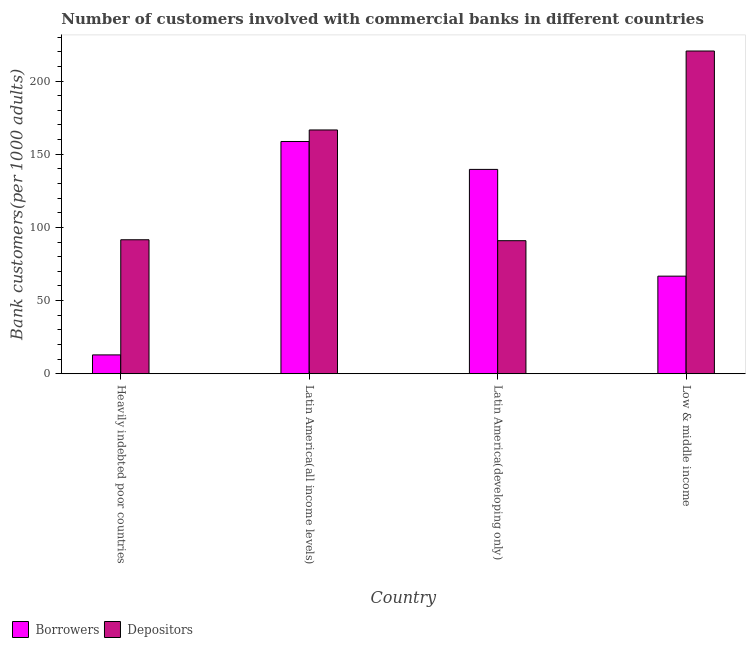How many groups of bars are there?
Give a very brief answer. 4. Are the number of bars on each tick of the X-axis equal?
Your response must be concise. Yes. How many bars are there on the 1st tick from the left?
Offer a very short reply. 2. What is the label of the 1st group of bars from the left?
Your response must be concise. Heavily indebted poor countries. What is the number of borrowers in Low & middle income?
Offer a terse response. 66.68. Across all countries, what is the maximum number of depositors?
Your answer should be compact. 220.51. Across all countries, what is the minimum number of borrowers?
Your response must be concise. 12.87. In which country was the number of depositors maximum?
Your answer should be very brief. Low & middle income. In which country was the number of depositors minimum?
Your response must be concise. Latin America(developing only). What is the total number of borrowers in the graph?
Offer a very short reply. 377.86. What is the difference between the number of borrowers in Heavily indebted poor countries and that in Low & middle income?
Make the answer very short. -53.8. What is the difference between the number of depositors in Latin America(all income levels) and the number of borrowers in Low & middle income?
Offer a very short reply. 99.89. What is the average number of depositors per country?
Ensure brevity in your answer.  142.38. What is the difference between the number of borrowers and number of depositors in Latin America(developing only)?
Provide a succinct answer. 48.71. In how many countries, is the number of depositors greater than 210 ?
Your answer should be compact. 1. What is the ratio of the number of depositors in Latin America(all income levels) to that in Latin America(developing only)?
Ensure brevity in your answer.  1.83. Is the difference between the number of depositors in Latin America(all income levels) and Latin America(developing only) greater than the difference between the number of borrowers in Latin America(all income levels) and Latin America(developing only)?
Provide a short and direct response. Yes. What is the difference between the highest and the second highest number of depositors?
Your response must be concise. 53.94. What is the difference between the highest and the lowest number of borrowers?
Offer a very short reply. 145.81. In how many countries, is the number of borrowers greater than the average number of borrowers taken over all countries?
Your answer should be very brief. 2. Is the sum of the number of depositors in Heavily indebted poor countries and Low & middle income greater than the maximum number of borrowers across all countries?
Provide a short and direct response. Yes. What does the 2nd bar from the left in Low & middle income represents?
Make the answer very short. Depositors. What does the 1st bar from the right in Low & middle income represents?
Provide a short and direct response. Depositors. How many countries are there in the graph?
Make the answer very short. 4. How many legend labels are there?
Provide a short and direct response. 2. How are the legend labels stacked?
Offer a terse response. Horizontal. What is the title of the graph?
Offer a terse response. Number of customers involved with commercial banks in different countries. Does "Lower secondary education" appear as one of the legend labels in the graph?
Give a very brief answer. No. What is the label or title of the Y-axis?
Provide a succinct answer. Bank customers(per 1000 adults). What is the Bank customers(per 1000 adults) in Borrowers in Heavily indebted poor countries?
Provide a succinct answer. 12.87. What is the Bank customers(per 1000 adults) of Depositors in Heavily indebted poor countries?
Your response must be concise. 91.54. What is the Bank customers(per 1000 adults) in Borrowers in Latin America(all income levels)?
Provide a succinct answer. 158.68. What is the Bank customers(per 1000 adults) of Depositors in Latin America(all income levels)?
Your answer should be very brief. 166.57. What is the Bank customers(per 1000 adults) in Borrowers in Latin America(developing only)?
Your response must be concise. 139.62. What is the Bank customers(per 1000 adults) of Depositors in Latin America(developing only)?
Your response must be concise. 90.91. What is the Bank customers(per 1000 adults) of Borrowers in Low & middle income?
Provide a succinct answer. 66.68. What is the Bank customers(per 1000 adults) of Depositors in Low & middle income?
Offer a terse response. 220.51. Across all countries, what is the maximum Bank customers(per 1000 adults) of Borrowers?
Give a very brief answer. 158.68. Across all countries, what is the maximum Bank customers(per 1000 adults) of Depositors?
Offer a very short reply. 220.51. Across all countries, what is the minimum Bank customers(per 1000 adults) in Borrowers?
Keep it short and to the point. 12.87. Across all countries, what is the minimum Bank customers(per 1000 adults) of Depositors?
Provide a succinct answer. 90.91. What is the total Bank customers(per 1000 adults) of Borrowers in the graph?
Give a very brief answer. 377.86. What is the total Bank customers(per 1000 adults) of Depositors in the graph?
Keep it short and to the point. 569.53. What is the difference between the Bank customers(per 1000 adults) in Borrowers in Heavily indebted poor countries and that in Latin America(all income levels)?
Offer a terse response. -145.81. What is the difference between the Bank customers(per 1000 adults) in Depositors in Heavily indebted poor countries and that in Latin America(all income levels)?
Keep it short and to the point. -75.03. What is the difference between the Bank customers(per 1000 adults) in Borrowers in Heavily indebted poor countries and that in Latin America(developing only)?
Ensure brevity in your answer.  -126.75. What is the difference between the Bank customers(per 1000 adults) in Depositors in Heavily indebted poor countries and that in Latin America(developing only)?
Offer a very short reply. 0.63. What is the difference between the Bank customers(per 1000 adults) of Borrowers in Heavily indebted poor countries and that in Low & middle income?
Give a very brief answer. -53.8. What is the difference between the Bank customers(per 1000 adults) in Depositors in Heavily indebted poor countries and that in Low & middle income?
Your answer should be compact. -128.97. What is the difference between the Bank customers(per 1000 adults) of Borrowers in Latin America(all income levels) and that in Latin America(developing only)?
Give a very brief answer. 19.06. What is the difference between the Bank customers(per 1000 adults) in Depositors in Latin America(all income levels) and that in Latin America(developing only)?
Your answer should be very brief. 75.66. What is the difference between the Bank customers(per 1000 adults) in Borrowers in Latin America(all income levels) and that in Low & middle income?
Ensure brevity in your answer.  92.01. What is the difference between the Bank customers(per 1000 adults) in Depositors in Latin America(all income levels) and that in Low & middle income?
Your answer should be very brief. -53.94. What is the difference between the Bank customers(per 1000 adults) in Borrowers in Latin America(developing only) and that in Low & middle income?
Ensure brevity in your answer.  72.95. What is the difference between the Bank customers(per 1000 adults) in Depositors in Latin America(developing only) and that in Low & middle income?
Your response must be concise. -129.6. What is the difference between the Bank customers(per 1000 adults) of Borrowers in Heavily indebted poor countries and the Bank customers(per 1000 adults) of Depositors in Latin America(all income levels)?
Make the answer very short. -153.69. What is the difference between the Bank customers(per 1000 adults) of Borrowers in Heavily indebted poor countries and the Bank customers(per 1000 adults) of Depositors in Latin America(developing only)?
Offer a terse response. -78.04. What is the difference between the Bank customers(per 1000 adults) of Borrowers in Heavily indebted poor countries and the Bank customers(per 1000 adults) of Depositors in Low & middle income?
Provide a short and direct response. -207.64. What is the difference between the Bank customers(per 1000 adults) of Borrowers in Latin America(all income levels) and the Bank customers(per 1000 adults) of Depositors in Latin America(developing only)?
Give a very brief answer. 67.77. What is the difference between the Bank customers(per 1000 adults) of Borrowers in Latin America(all income levels) and the Bank customers(per 1000 adults) of Depositors in Low & middle income?
Make the answer very short. -61.83. What is the difference between the Bank customers(per 1000 adults) in Borrowers in Latin America(developing only) and the Bank customers(per 1000 adults) in Depositors in Low & middle income?
Offer a terse response. -80.89. What is the average Bank customers(per 1000 adults) of Borrowers per country?
Offer a terse response. 94.47. What is the average Bank customers(per 1000 adults) of Depositors per country?
Offer a terse response. 142.38. What is the difference between the Bank customers(per 1000 adults) of Borrowers and Bank customers(per 1000 adults) of Depositors in Heavily indebted poor countries?
Offer a very short reply. -78.67. What is the difference between the Bank customers(per 1000 adults) in Borrowers and Bank customers(per 1000 adults) in Depositors in Latin America(all income levels)?
Your answer should be compact. -7.88. What is the difference between the Bank customers(per 1000 adults) in Borrowers and Bank customers(per 1000 adults) in Depositors in Latin America(developing only)?
Offer a very short reply. 48.71. What is the difference between the Bank customers(per 1000 adults) in Borrowers and Bank customers(per 1000 adults) in Depositors in Low & middle income?
Make the answer very short. -153.83. What is the ratio of the Bank customers(per 1000 adults) of Borrowers in Heavily indebted poor countries to that in Latin America(all income levels)?
Provide a short and direct response. 0.08. What is the ratio of the Bank customers(per 1000 adults) in Depositors in Heavily indebted poor countries to that in Latin America(all income levels)?
Offer a very short reply. 0.55. What is the ratio of the Bank customers(per 1000 adults) in Borrowers in Heavily indebted poor countries to that in Latin America(developing only)?
Offer a very short reply. 0.09. What is the ratio of the Bank customers(per 1000 adults) of Borrowers in Heavily indebted poor countries to that in Low & middle income?
Your response must be concise. 0.19. What is the ratio of the Bank customers(per 1000 adults) in Depositors in Heavily indebted poor countries to that in Low & middle income?
Keep it short and to the point. 0.42. What is the ratio of the Bank customers(per 1000 adults) of Borrowers in Latin America(all income levels) to that in Latin America(developing only)?
Offer a terse response. 1.14. What is the ratio of the Bank customers(per 1000 adults) in Depositors in Latin America(all income levels) to that in Latin America(developing only)?
Your answer should be very brief. 1.83. What is the ratio of the Bank customers(per 1000 adults) of Borrowers in Latin America(all income levels) to that in Low & middle income?
Offer a terse response. 2.38. What is the ratio of the Bank customers(per 1000 adults) of Depositors in Latin America(all income levels) to that in Low & middle income?
Give a very brief answer. 0.76. What is the ratio of the Bank customers(per 1000 adults) in Borrowers in Latin America(developing only) to that in Low & middle income?
Offer a very short reply. 2.09. What is the ratio of the Bank customers(per 1000 adults) in Depositors in Latin America(developing only) to that in Low & middle income?
Offer a terse response. 0.41. What is the difference between the highest and the second highest Bank customers(per 1000 adults) of Borrowers?
Your answer should be very brief. 19.06. What is the difference between the highest and the second highest Bank customers(per 1000 adults) in Depositors?
Offer a terse response. 53.94. What is the difference between the highest and the lowest Bank customers(per 1000 adults) of Borrowers?
Your answer should be very brief. 145.81. What is the difference between the highest and the lowest Bank customers(per 1000 adults) in Depositors?
Ensure brevity in your answer.  129.6. 